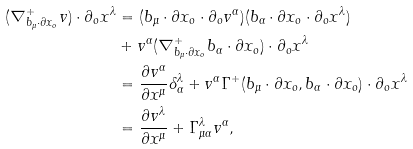<formula> <loc_0><loc_0><loc_500><loc_500>( \nabla _ { b _ { \mu } \cdot \partial x _ { o } } ^ { + } v ) \cdot \partial _ { o } x ^ { \lambda } & = ( b _ { \mu } \cdot \partial x _ { o } \cdot \partial _ { o } v ^ { \alpha } ) ( b _ { \alpha } \cdot \partial x _ { o } \cdot \partial _ { o } x ^ { \lambda } ) \\ & + v ^ { \alpha } ( \nabla _ { b _ { \mu } \cdot \partial x _ { o } } ^ { + } b _ { \alpha } \cdot \partial x _ { o } ) \cdot \partial _ { o } x ^ { \lambda } \\ & = \frac { \partial v ^ { \alpha } } { \partial x ^ { \mu } } \delta _ { \alpha } ^ { \lambda } + v ^ { \alpha } \Gamma ^ { + } ( b _ { \mu } \cdot \partial x _ { o } , b _ { \alpha } \cdot \partial x _ { o } ) \cdot \partial _ { o } x ^ { \lambda } \\ & = \frac { \partial v ^ { \lambda } } { \partial x ^ { \mu } } + \Gamma _ { \mu \alpha } ^ { \lambda } v ^ { \alpha } ,</formula> 